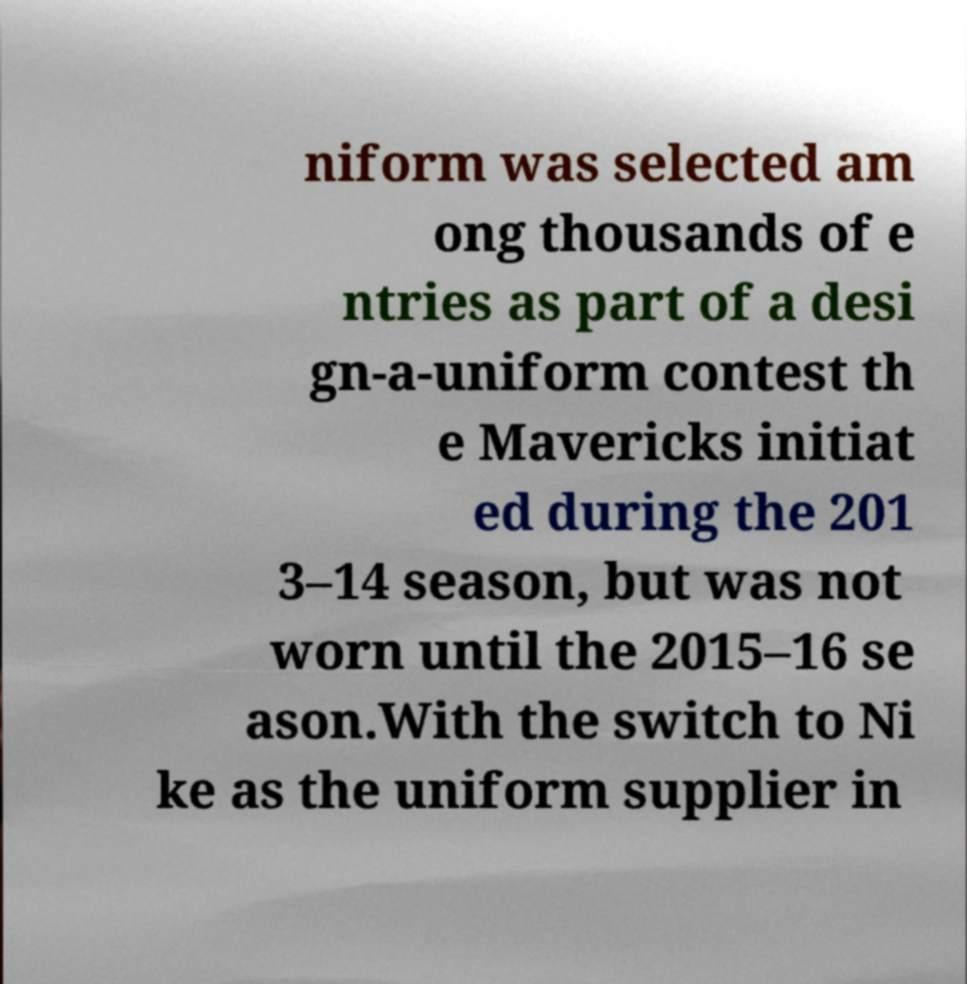Please read and relay the text visible in this image. What does it say? niform was selected am ong thousands of e ntries as part of a desi gn-a-uniform contest th e Mavericks initiat ed during the 201 3–14 season, but was not worn until the 2015–16 se ason.With the switch to Ni ke as the uniform supplier in 